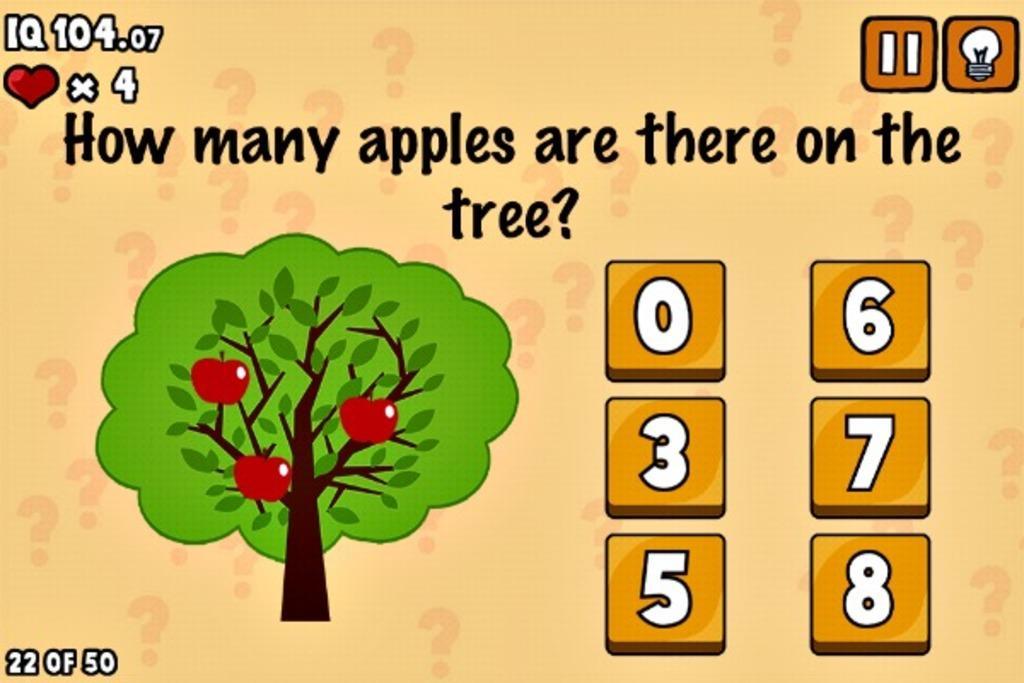Can you describe this image briefly? This is an animated picture. The picture looks like a screenshot. In this picture there are numbers, text, tree, apples and other objects. 